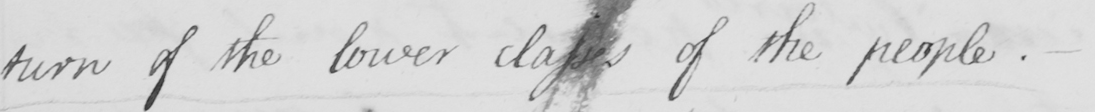Please transcribe the handwritten text in this image. turn of the lower classes of the people. 